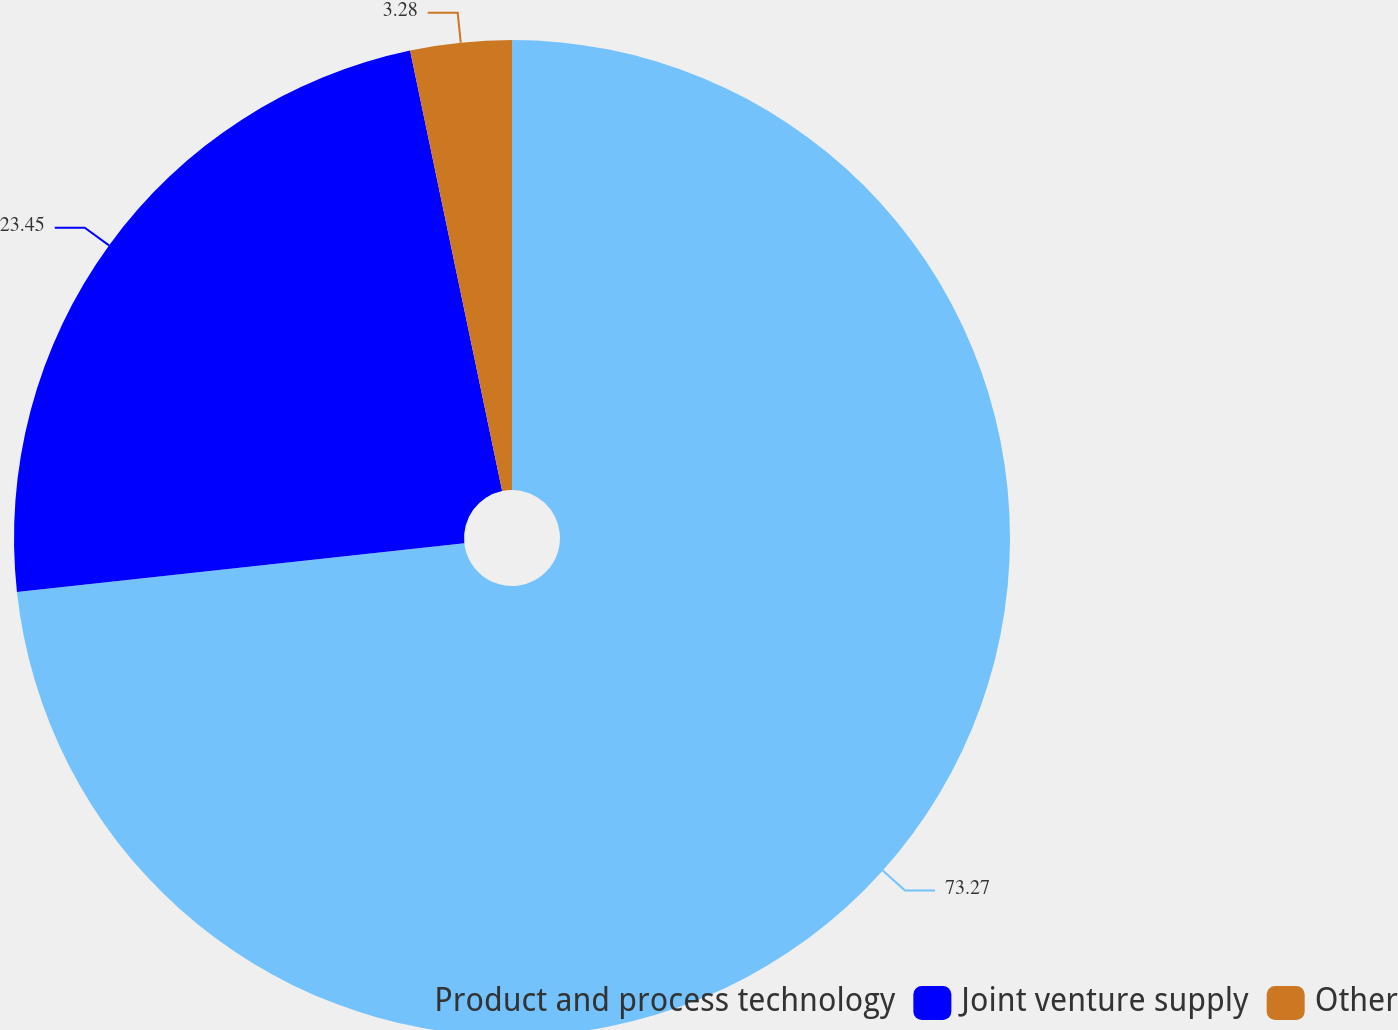Convert chart. <chart><loc_0><loc_0><loc_500><loc_500><pie_chart><fcel>Product and process technology<fcel>Joint venture supply<fcel>Other<nl><fcel>73.27%<fcel>23.45%<fcel>3.28%<nl></chart> 